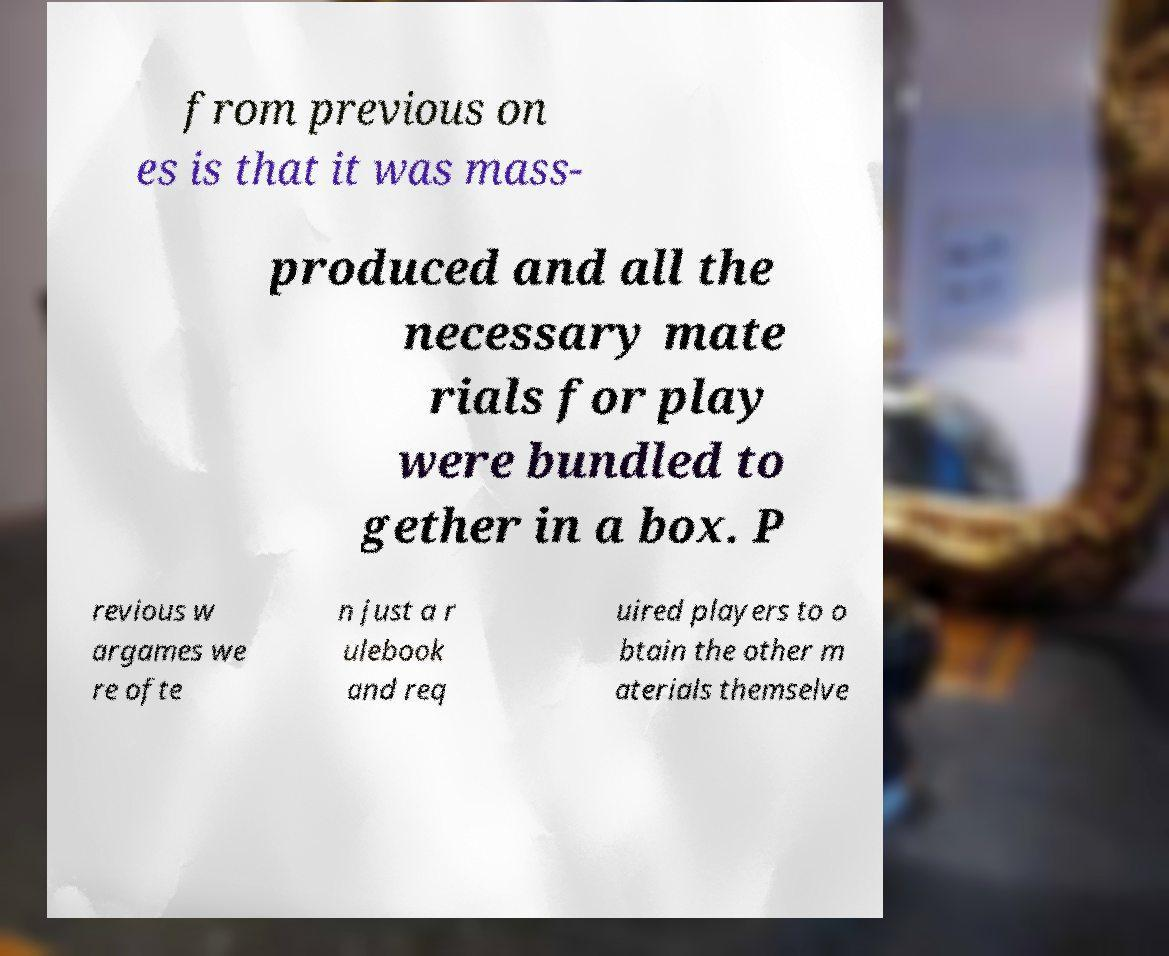What messages or text are displayed in this image? I need them in a readable, typed format. from previous on es is that it was mass- produced and all the necessary mate rials for play were bundled to gether in a box. P revious w argames we re ofte n just a r ulebook and req uired players to o btain the other m aterials themselve 